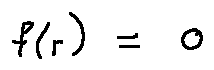Convert formula to latex. <formula><loc_0><loc_0><loc_500><loc_500>f ( r ) = 0</formula> 